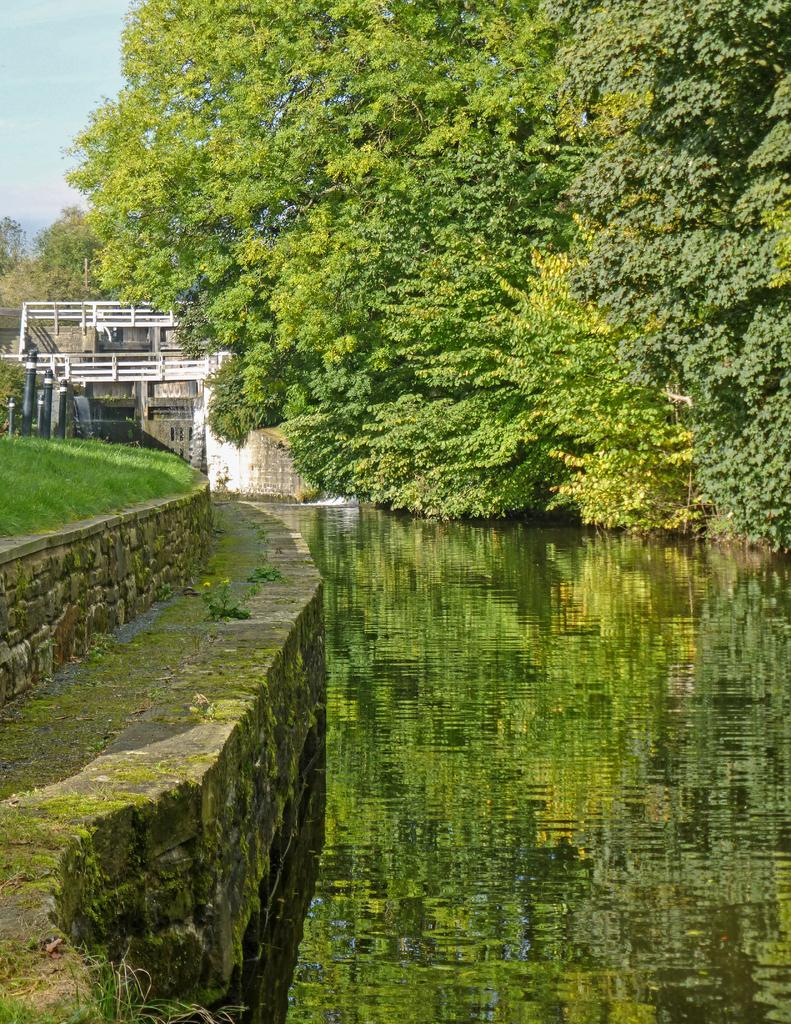What type of natural scenery can be seen in the background of the image? There are trees in the background of the image. What is visible at the bottom of the image? There is water visible at the bottom of the image. What type of wire is being used to play chess in the image? There is no wire or chess game present in the image. 